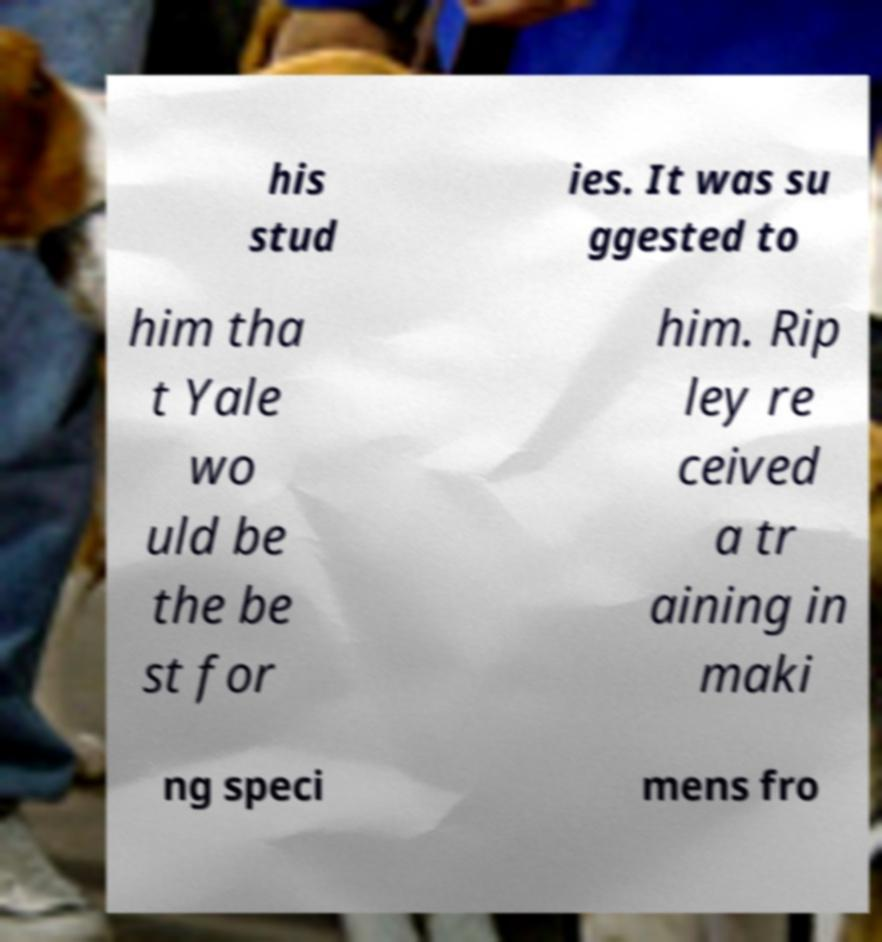Can you accurately transcribe the text from the provided image for me? his stud ies. It was su ggested to him tha t Yale wo uld be the be st for him. Rip ley re ceived a tr aining in maki ng speci mens fro 